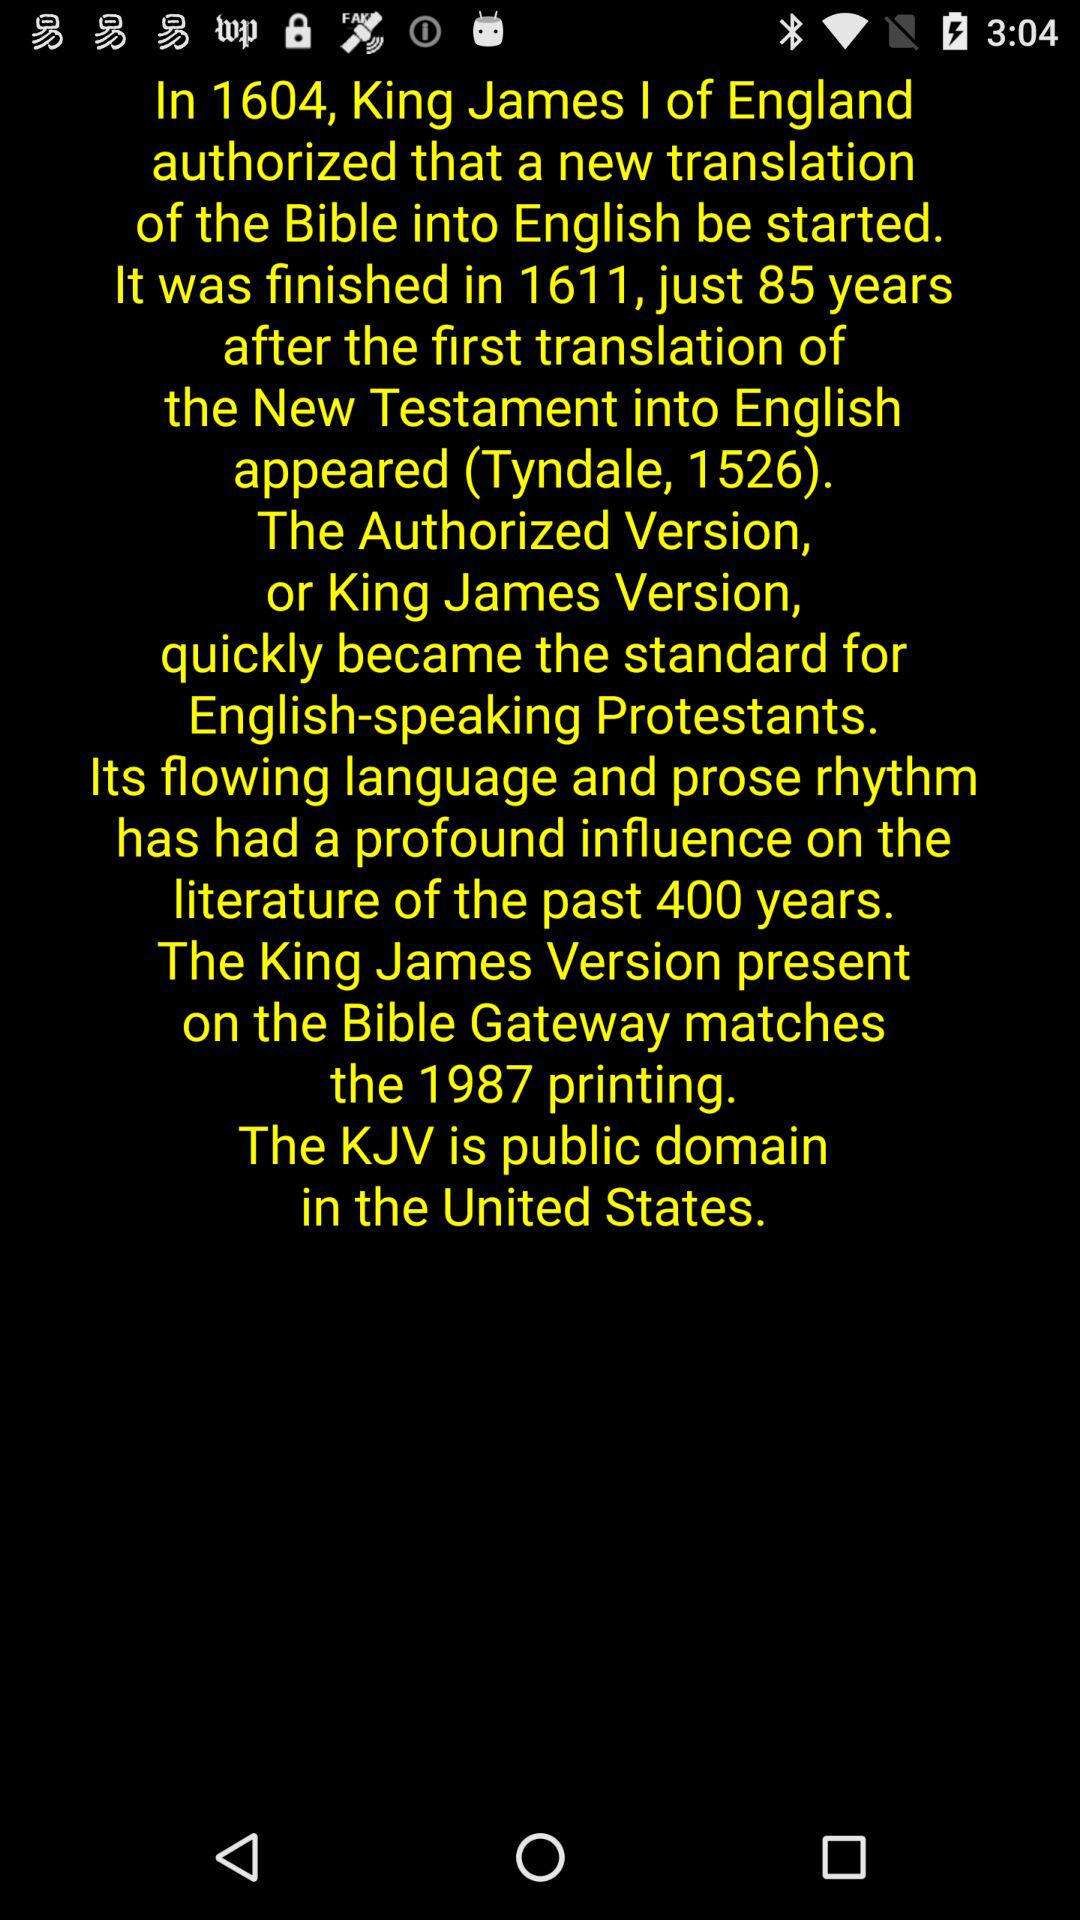What does KJV stand for? KJV stands for the King James Version. 